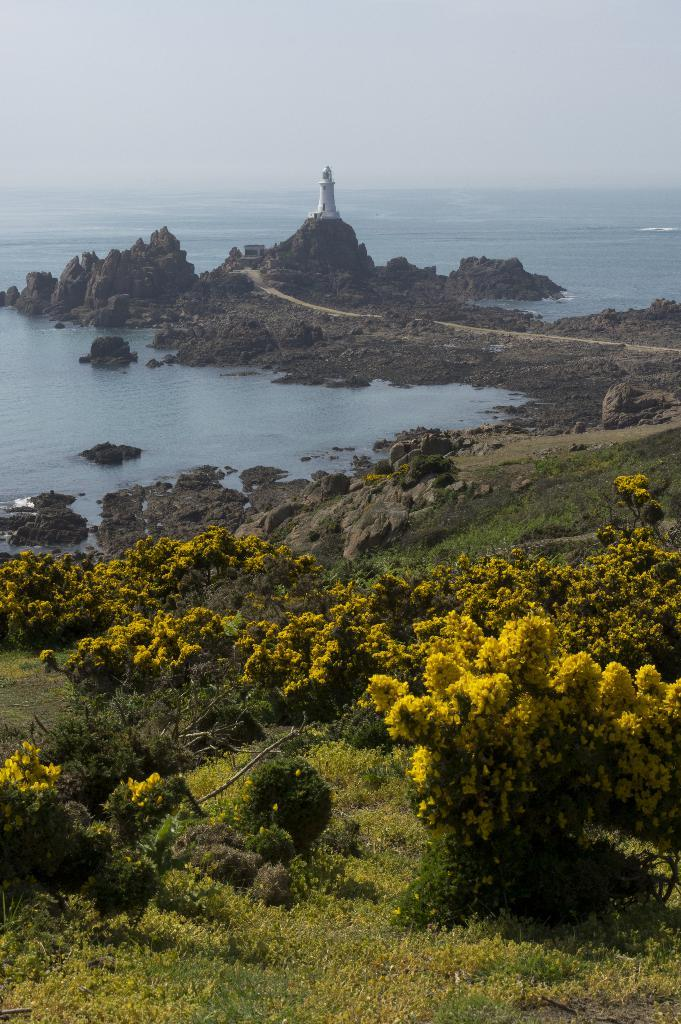What type of living organisms can be seen in the image? Plants are visible in the image. What color is the grass on the ground? The grass on the ground is green. What large body of water is depicted in the image? The image appears to depict an ocean in the front. What type of structure is present in the image? There is a small house in the image. What is visible at the top of the image? The sky is visible at the top of the image. What type of agreement is being discussed by the plants in the image? There are no plants capable of discussing agreements in the image. How does the throat of the ocean in the image appear? The image depicts an ocean, not a throat, so this question is not applicable. 